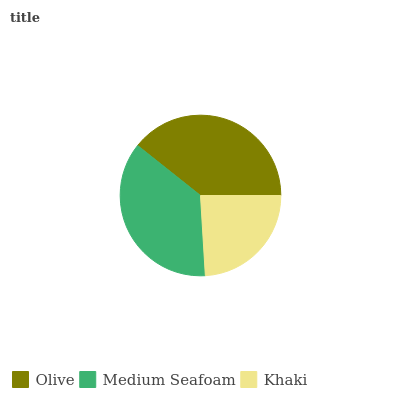Is Khaki the minimum?
Answer yes or no. Yes. Is Olive the maximum?
Answer yes or no. Yes. Is Medium Seafoam the minimum?
Answer yes or no. No. Is Medium Seafoam the maximum?
Answer yes or no. No. Is Olive greater than Medium Seafoam?
Answer yes or no. Yes. Is Medium Seafoam less than Olive?
Answer yes or no. Yes. Is Medium Seafoam greater than Olive?
Answer yes or no. No. Is Olive less than Medium Seafoam?
Answer yes or no. No. Is Medium Seafoam the high median?
Answer yes or no. Yes. Is Medium Seafoam the low median?
Answer yes or no. Yes. Is Olive the high median?
Answer yes or no. No. Is Khaki the low median?
Answer yes or no. No. 